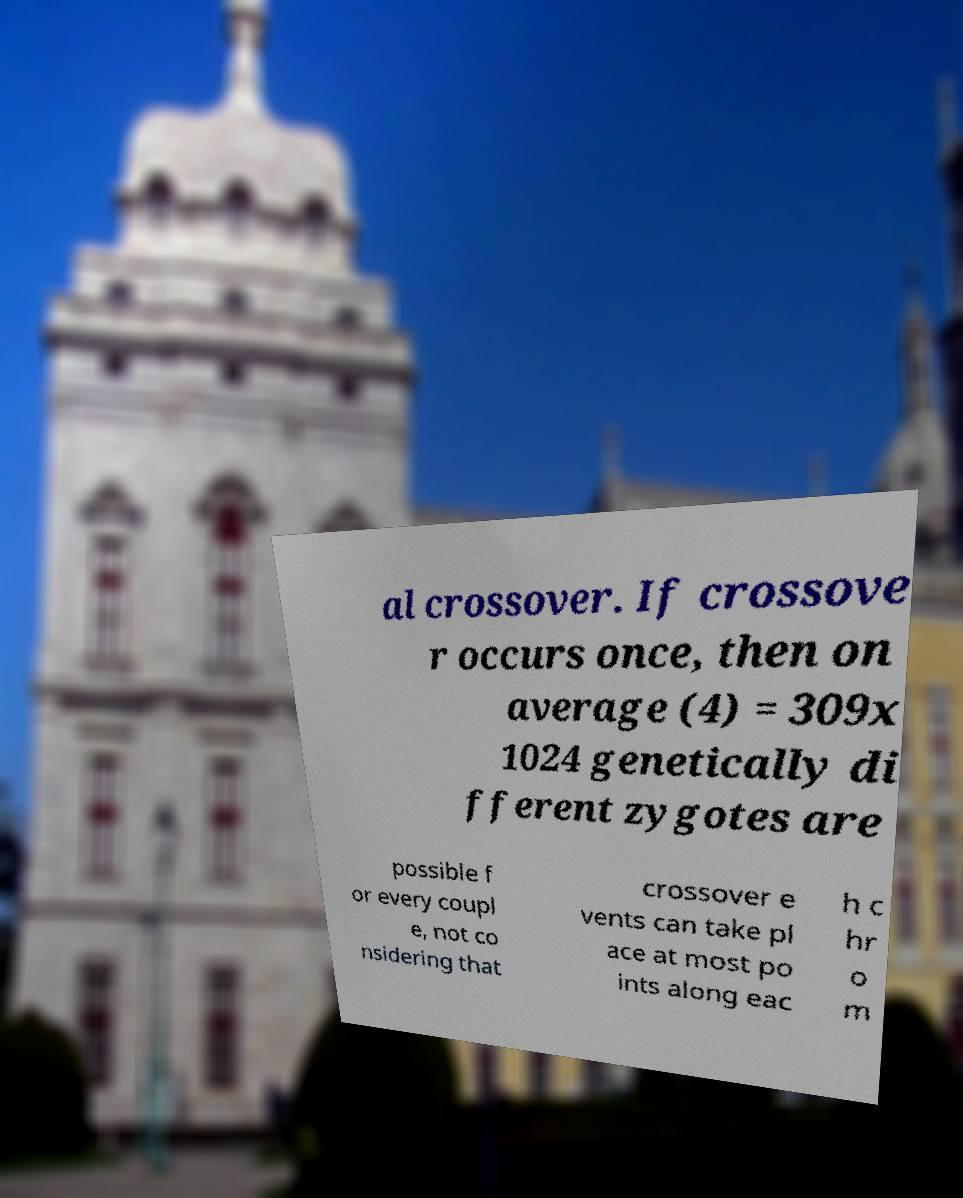There's text embedded in this image that I need extracted. Can you transcribe it verbatim? al crossover. If crossove r occurs once, then on average (4) = 309x 1024 genetically di fferent zygotes are possible f or every coupl e, not co nsidering that crossover e vents can take pl ace at most po ints along eac h c hr o m 